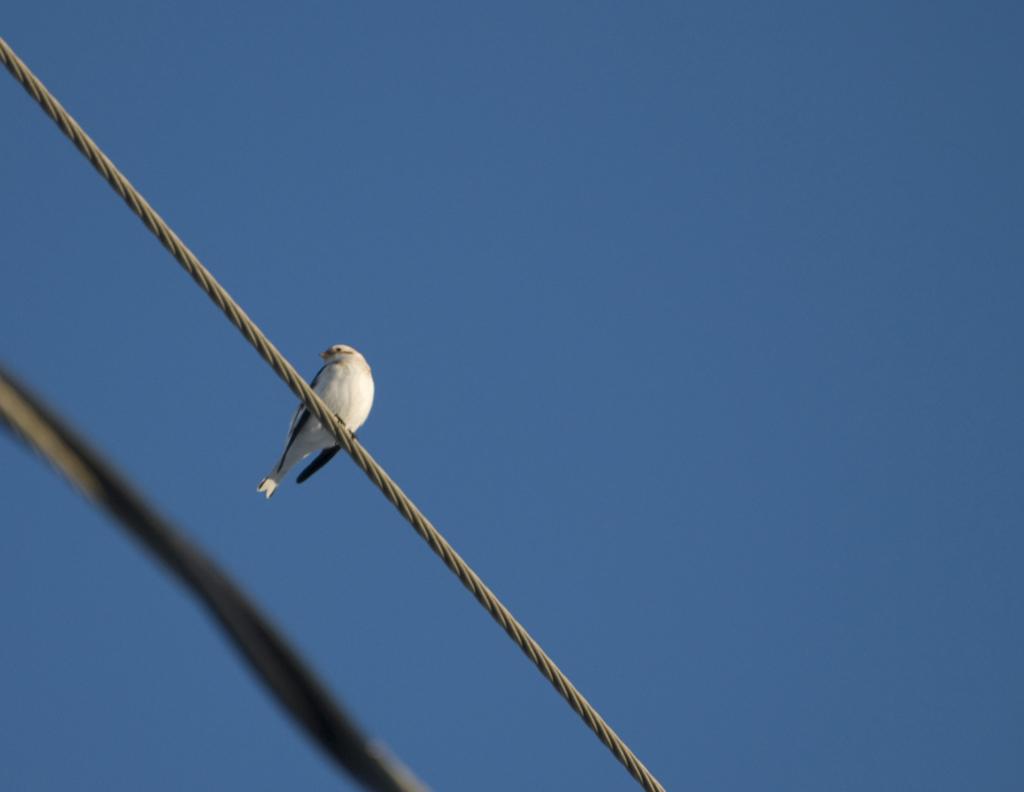Could you give a brief overview of what you see in this image? This picture is clicked outside. On the left there is a bird standing on a cable. On the left corner there is an object. In the background there is a sky. 